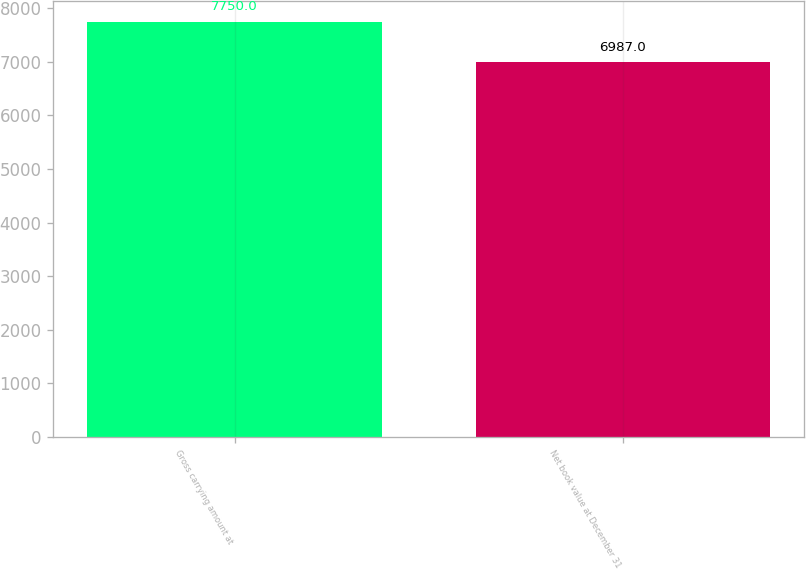Convert chart to OTSL. <chart><loc_0><loc_0><loc_500><loc_500><bar_chart><fcel>Gross carrying amount at<fcel>Net book value at December 31<nl><fcel>7750<fcel>6987<nl></chart> 